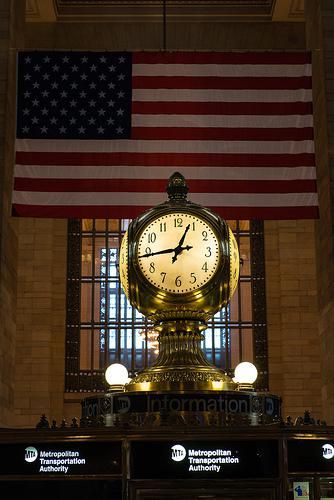Question: where was this photo taken?
Choices:
A. Bus station.
B. Boat launch.
C. Airport.
D. Train station.
Answer with the letter. Answer: D Question: what time was this photo taken?
Choices:
A. 5:45 pm.
B. 12:45 PM.
C. 4:37 am.
D. 4:29 pm.
Answer with the letter. Answer: B Question: who is standing under the clock?
Choices:
A. Teacher.
B. Student.
C. Child.
D. No one.
Answer with the letter. Answer: D Question: what three colors are the flag?
Choices:
A. Black, white, red.
B. Yellow, blue, red.
C. Red, white, blue.
D. Red, black, green.
Answer with the letter. Answer: C Question: what is the short form of "Metropolitan Transportation Authority"?
Choices:
A. Metro.
B. MetroTA.
C. MTA.
D. Metro Trans.
Answer with the letter. Answer: C 